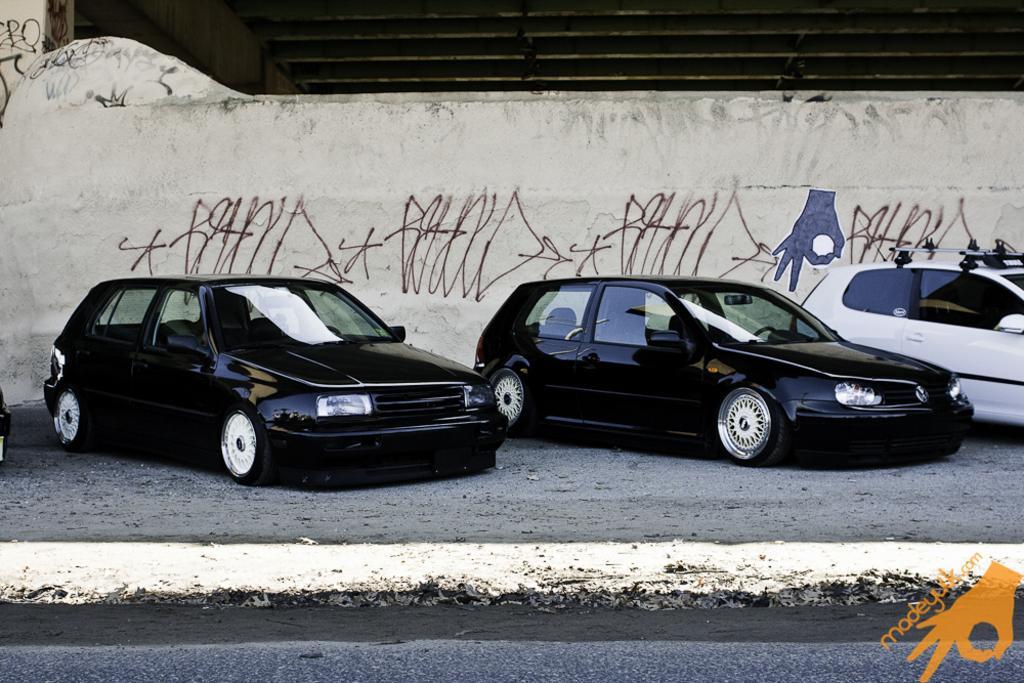Describe this image in one or two sentences. In the image I can see three cars which are parked on the side and behind there is a wall on which there is something written. 